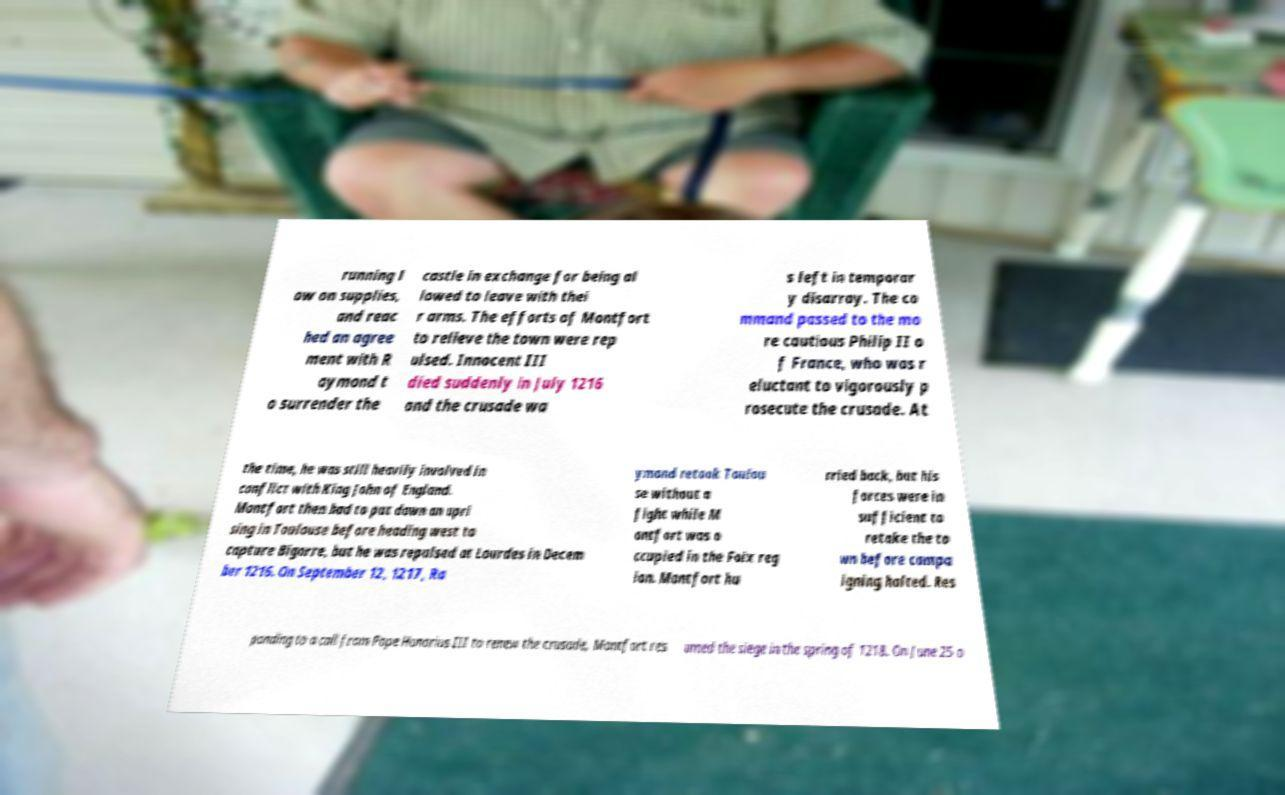Can you read and provide the text displayed in the image?This photo seems to have some interesting text. Can you extract and type it out for me? running l ow on supplies, and reac hed an agree ment with R aymond t o surrender the castle in exchange for being al lowed to leave with thei r arms. The efforts of Montfort to relieve the town were rep ulsed. Innocent III died suddenly in July 1216 and the crusade wa s left in temporar y disarray. The co mmand passed to the mo re cautious Philip II o f France, who was r eluctant to vigorously p rosecute the crusade. At the time, he was still heavily involved in conflict with King John of England. Montfort then had to put down an upri sing in Toulouse before heading west to capture Bigorre, but he was repulsed at Lourdes in Decem ber 1216. On September 12, 1217, Ra ymond retook Toulou se without a fight while M ontfort was o ccupied in the Foix reg ion. Montfort hu rried back, but his forces were in sufficient to retake the to wn before campa igning halted. Res ponding to a call from Pope Honorius III to renew the crusade, Montfort res umed the siege in the spring of 1218. On June 25 o 